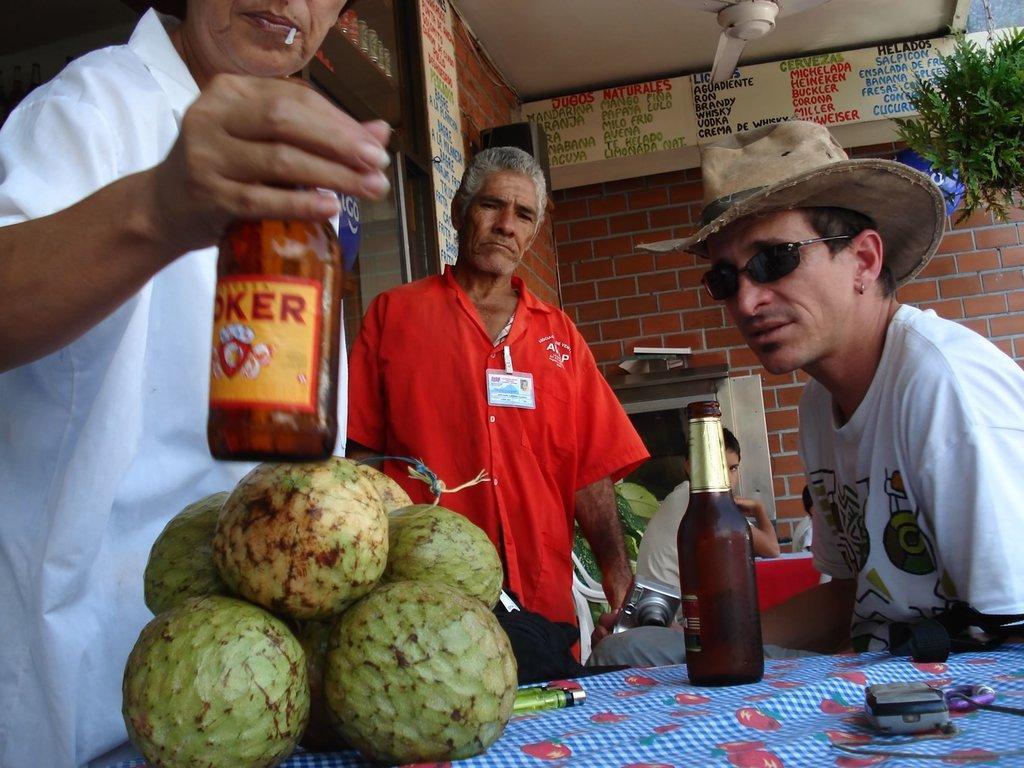How would you summarize this image in a sentence or two? In the picture there are total four persons two of them are sitting two of them are standing , the person who is standing to the left side he is holding some bottle in his hand and he is also holding something in his mouth also, there is a table in front of them on the table there is a lighter , a bottle and also some fruits , there is a red color and blue color cloth on the table in the background there are some food items list written on the board and a tree , behind it there is a red color brick wall. 